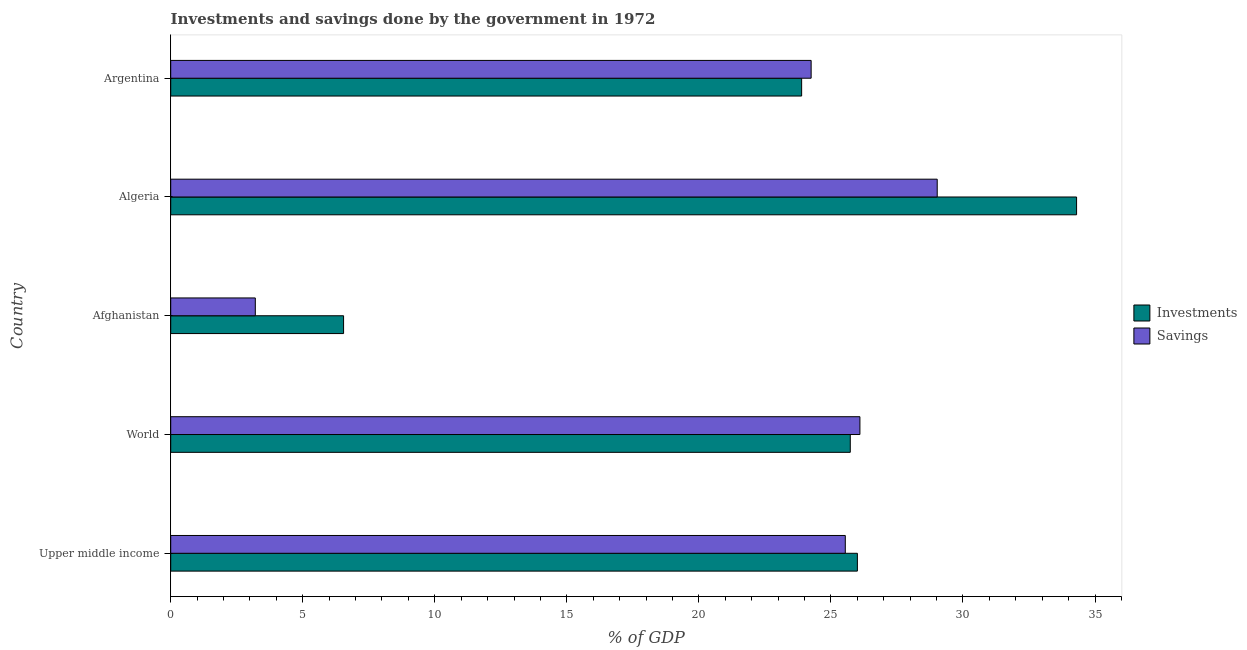How many different coloured bars are there?
Ensure brevity in your answer.  2. Are the number of bars per tick equal to the number of legend labels?
Your answer should be very brief. Yes. Are the number of bars on each tick of the Y-axis equal?
Your answer should be very brief. Yes. What is the label of the 5th group of bars from the top?
Your answer should be very brief. Upper middle income. What is the savings of government in World?
Provide a succinct answer. 26.1. Across all countries, what is the maximum savings of government?
Provide a succinct answer. 29.03. Across all countries, what is the minimum investments of government?
Your response must be concise. 6.55. In which country was the savings of government maximum?
Keep it short and to the point. Algeria. In which country was the savings of government minimum?
Provide a succinct answer. Afghanistan. What is the total investments of government in the graph?
Make the answer very short. 116.48. What is the difference between the investments of government in Upper middle income and that in World?
Offer a very short reply. 0.27. What is the difference between the savings of government in Argentina and the investments of government in World?
Your answer should be very brief. -1.48. What is the average investments of government per country?
Provide a succinct answer. 23.3. What is the difference between the savings of government and investments of government in Algeria?
Provide a succinct answer. -5.28. In how many countries, is the investments of government greater than 14 %?
Your answer should be compact. 4. What is the ratio of the savings of government in Afghanistan to that in Upper middle income?
Your response must be concise. 0.12. Is the savings of government in Algeria less than that in Argentina?
Ensure brevity in your answer.  No. What is the difference between the highest and the second highest savings of government?
Provide a short and direct response. 2.93. What is the difference between the highest and the lowest investments of government?
Provide a short and direct response. 27.76. What does the 2nd bar from the top in Algeria represents?
Provide a succinct answer. Investments. What does the 2nd bar from the bottom in World represents?
Provide a succinct answer. Savings. How many bars are there?
Keep it short and to the point. 10. Are the values on the major ticks of X-axis written in scientific E-notation?
Your answer should be compact. No. Does the graph contain grids?
Offer a very short reply. No. What is the title of the graph?
Give a very brief answer. Investments and savings done by the government in 1972. What is the label or title of the X-axis?
Your response must be concise. % of GDP. What is the label or title of the Y-axis?
Your response must be concise. Country. What is the % of GDP in Investments in Upper middle income?
Your response must be concise. 26. What is the % of GDP of Savings in Upper middle income?
Keep it short and to the point. 25.54. What is the % of GDP of Investments in World?
Provide a succinct answer. 25.73. What is the % of GDP in Savings in World?
Provide a short and direct response. 26.1. What is the % of GDP of Investments in Afghanistan?
Your response must be concise. 6.55. What is the % of GDP in Savings in Afghanistan?
Offer a terse response. 3.2. What is the % of GDP of Investments in Algeria?
Ensure brevity in your answer.  34.3. What is the % of GDP in Savings in Algeria?
Give a very brief answer. 29.03. What is the % of GDP of Investments in Argentina?
Your response must be concise. 23.89. What is the % of GDP of Savings in Argentina?
Provide a succinct answer. 24.25. Across all countries, what is the maximum % of GDP in Investments?
Offer a very short reply. 34.3. Across all countries, what is the maximum % of GDP in Savings?
Keep it short and to the point. 29.03. Across all countries, what is the minimum % of GDP in Investments?
Keep it short and to the point. 6.55. Across all countries, what is the minimum % of GDP in Savings?
Offer a very short reply. 3.2. What is the total % of GDP of Investments in the graph?
Your response must be concise. 116.48. What is the total % of GDP of Savings in the graph?
Provide a short and direct response. 108.12. What is the difference between the % of GDP of Investments in Upper middle income and that in World?
Make the answer very short. 0.27. What is the difference between the % of GDP in Savings in Upper middle income and that in World?
Keep it short and to the point. -0.55. What is the difference between the % of GDP of Investments in Upper middle income and that in Afghanistan?
Make the answer very short. 19.46. What is the difference between the % of GDP in Savings in Upper middle income and that in Afghanistan?
Offer a very short reply. 22.34. What is the difference between the % of GDP in Investments in Upper middle income and that in Algeria?
Provide a succinct answer. -8.3. What is the difference between the % of GDP of Savings in Upper middle income and that in Algeria?
Provide a short and direct response. -3.48. What is the difference between the % of GDP of Investments in Upper middle income and that in Argentina?
Give a very brief answer. 2.11. What is the difference between the % of GDP in Savings in Upper middle income and that in Argentina?
Give a very brief answer. 1.29. What is the difference between the % of GDP of Investments in World and that in Afghanistan?
Ensure brevity in your answer.  19.19. What is the difference between the % of GDP in Savings in World and that in Afghanistan?
Your answer should be very brief. 22.89. What is the difference between the % of GDP of Investments in World and that in Algeria?
Your answer should be very brief. -8.57. What is the difference between the % of GDP of Savings in World and that in Algeria?
Your response must be concise. -2.93. What is the difference between the % of GDP of Investments in World and that in Argentina?
Your answer should be compact. 1.84. What is the difference between the % of GDP in Savings in World and that in Argentina?
Keep it short and to the point. 1.85. What is the difference between the % of GDP in Investments in Afghanistan and that in Algeria?
Your response must be concise. -27.76. What is the difference between the % of GDP in Savings in Afghanistan and that in Algeria?
Your answer should be compact. -25.82. What is the difference between the % of GDP of Investments in Afghanistan and that in Argentina?
Your answer should be compact. -17.35. What is the difference between the % of GDP in Savings in Afghanistan and that in Argentina?
Ensure brevity in your answer.  -21.05. What is the difference between the % of GDP in Investments in Algeria and that in Argentina?
Ensure brevity in your answer.  10.41. What is the difference between the % of GDP of Savings in Algeria and that in Argentina?
Your response must be concise. 4.77. What is the difference between the % of GDP in Investments in Upper middle income and the % of GDP in Savings in World?
Ensure brevity in your answer.  -0.1. What is the difference between the % of GDP of Investments in Upper middle income and the % of GDP of Savings in Afghanistan?
Your response must be concise. 22.8. What is the difference between the % of GDP in Investments in Upper middle income and the % of GDP in Savings in Algeria?
Make the answer very short. -3.02. What is the difference between the % of GDP of Investments in Upper middle income and the % of GDP of Savings in Argentina?
Provide a succinct answer. 1.75. What is the difference between the % of GDP in Investments in World and the % of GDP in Savings in Afghanistan?
Offer a terse response. 22.53. What is the difference between the % of GDP of Investments in World and the % of GDP of Savings in Algeria?
Provide a short and direct response. -3.29. What is the difference between the % of GDP in Investments in World and the % of GDP in Savings in Argentina?
Ensure brevity in your answer.  1.48. What is the difference between the % of GDP of Investments in Afghanistan and the % of GDP of Savings in Algeria?
Offer a very short reply. -22.48. What is the difference between the % of GDP in Investments in Afghanistan and the % of GDP in Savings in Argentina?
Make the answer very short. -17.71. What is the difference between the % of GDP of Investments in Algeria and the % of GDP of Savings in Argentina?
Keep it short and to the point. 10.05. What is the average % of GDP in Investments per country?
Provide a short and direct response. 23.3. What is the average % of GDP of Savings per country?
Keep it short and to the point. 21.62. What is the difference between the % of GDP in Investments and % of GDP in Savings in Upper middle income?
Offer a very short reply. 0.46. What is the difference between the % of GDP in Investments and % of GDP in Savings in World?
Your response must be concise. -0.37. What is the difference between the % of GDP of Investments and % of GDP of Savings in Afghanistan?
Make the answer very short. 3.34. What is the difference between the % of GDP in Investments and % of GDP in Savings in Algeria?
Provide a short and direct response. 5.28. What is the difference between the % of GDP in Investments and % of GDP in Savings in Argentina?
Your answer should be compact. -0.36. What is the ratio of the % of GDP in Investments in Upper middle income to that in World?
Offer a very short reply. 1.01. What is the ratio of the % of GDP in Savings in Upper middle income to that in World?
Your answer should be compact. 0.98. What is the ratio of the % of GDP of Investments in Upper middle income to that in Afghanistan?
Offer a very short reply. 3.97. What is the ratio of the % of GDP in Savings in Upper middle income to that in Afghanistan?
Your answer should be very brief. 7.97. What is the ratio of the % of GDP of Investments in Upper middle income to that in Algeria?
Provide a short and direct response. 0.76. What is the ratio of the % of GDP in Savings in Upper middle income to that in Algeria?
Make the answer very short. 0.88. What is the ratio of the % of GDP in Investments in Upper middle income to that in Argentina?
Provide a succinct answer. 1.09. What is the ratio of the % of GDP in Savings in Upper middle income to that in Argentina?
Your answer should be very brief. 1.05. What is the ratio of the % of GDP of Investments in World to that in Afghanistan?
Your answer should be compact. 3.93. What is the ratio of the % of GDP of Savings in World to that in Afghanistan?
Provide a short and direct response. 8.15. What is the ratio of the % of GDP of Investments in World to that in Algeria?
Provide a succinct answer. 0.75. What is the ratio of the % of GDP of Savings in World to that in Algeria?
Give a very brief answer. 0.9. What is the ratio of the % of GDP in Investments in World to that in Argentina?
Give a very brief answer. 1.08. What is the ratio of the % of GDP of Savings in World to that in Argentina?
Ensure brevity in your answer.  1.08. What is the ratio of the % of GDP in Investments in Afghanistan to that in Algeria?
Provide a succinct answer. 0.19. What is the ratio of the % of GDP in Savings in Afghanistan to that in Algeria?
Your response must be concise. 0.11. What is the ratio of the % of GDP of Investments in Afghanistan to that in Argentina?
Ensure brevity in your answer.  0.27. What is the ratio of the % of GDP of Savings in Afghanistan to that in Argentina?
Provide a short and direct response. 0.13. What is the ratio of the % of GDP of Investments in Algeria to that in Argentina?
Provide a succinct answer. 1.44. What is the ratio of the % of GDP of Savings in Algeria to that in Argentina?
Offer a very short reply. 1.2. What is the difference between the highest and the second highest % of GDP of Investments?
Provide a succinct answer. 8.3. What is the difference between the highest and the second highest % of GDP of Savings?
Your answer should be very brief. 2.93. What is the difference between the highest and the lowest % of GDP in Investments?
Provide a short and direct response. 27.76. What is the difference between the highest and the lowest % of GDP of Savings?
Make the answer very short. 25.82. 